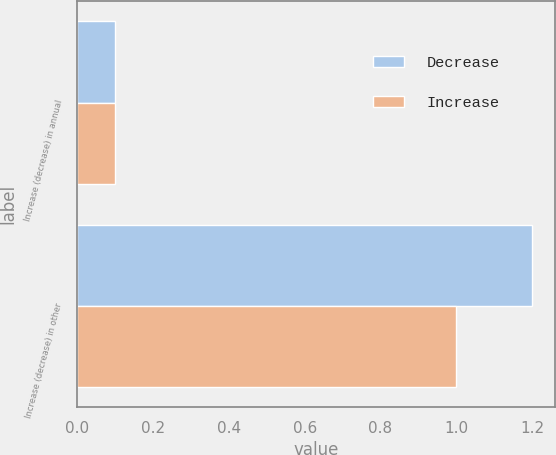<chart> <loc_0><loc_0><loc_500><loc_500><stacked_bar_chart><ecel><fcel>Increase (decrease) in annual<fcel>Increase (decrease) in other<nl><fcel>Decrease<fcel>0.1<fcel>1.2<nl><fcel>Increase<fcel>0.1<fcel>1<nl></chart> 